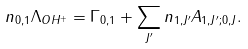Convert formula to latex. <formula><loc_0><loc_0><loc_500><loc_500>n _ { 0 , 1 } \Lambda _ { O H ^ { + } } = \Gamma _ { 0 , 1 } + \sum _ { J ^ { \prime } } n _ { 1 , J ^ { \prime } } A _ { 1 , J ^ { \prime } ; 0 , J } .</formula> 